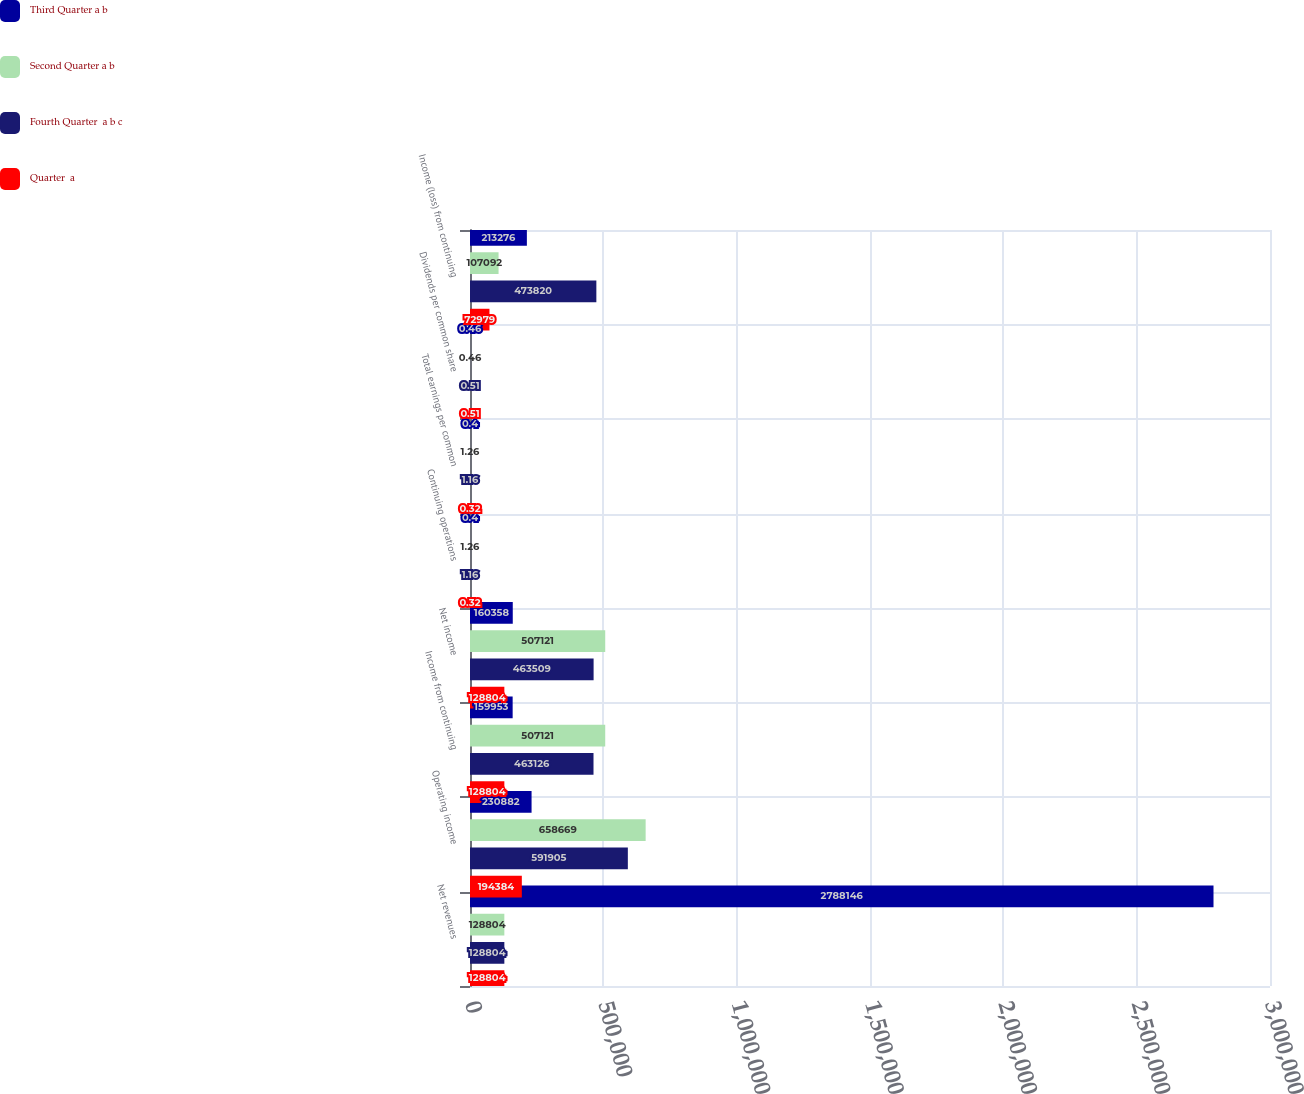Convert chart to OTSL. <chart><loc_0><loc_0><loc_500><loc_500><stacked_bar_chart><ecel><fcel>Net revenues<fcel>Operating income<fcel>Income from continuing<fcel>Net income<fcel>Continuing operations<fcel>Total earnings per common<fcel>Dividends per common share<fcel>Income (loss) from continuing<nl><fcel>Third Quarter a b<fcel>2.78815e+06<fcel>230882<fcel>159953<fcel>160358<fcel>0.4<fcel>0.4<fcel>0.46<fcel>213276<nl><fcel>Second Quarter a b<fcel>128804<fcel>658669<fcel>507121<fcel>507121<fcel>1.26<fcel>1.26<fcel>0.46<fcel>107092<nl><fcel>Fourth Quarter  a b c<fcel>128804<fcel>591905<fcel>463126<fcel>463509<fcel>1.16<fcel>1.16<fcel>0.51<fcel>473820<nl><fcel>Quarter  a<fcel>128804<fcel>194384<fcel>128804<fcel>128804<fcel>0.32<fcel>0.32<fcel>0.51<fcel>72979<nl></chart> 